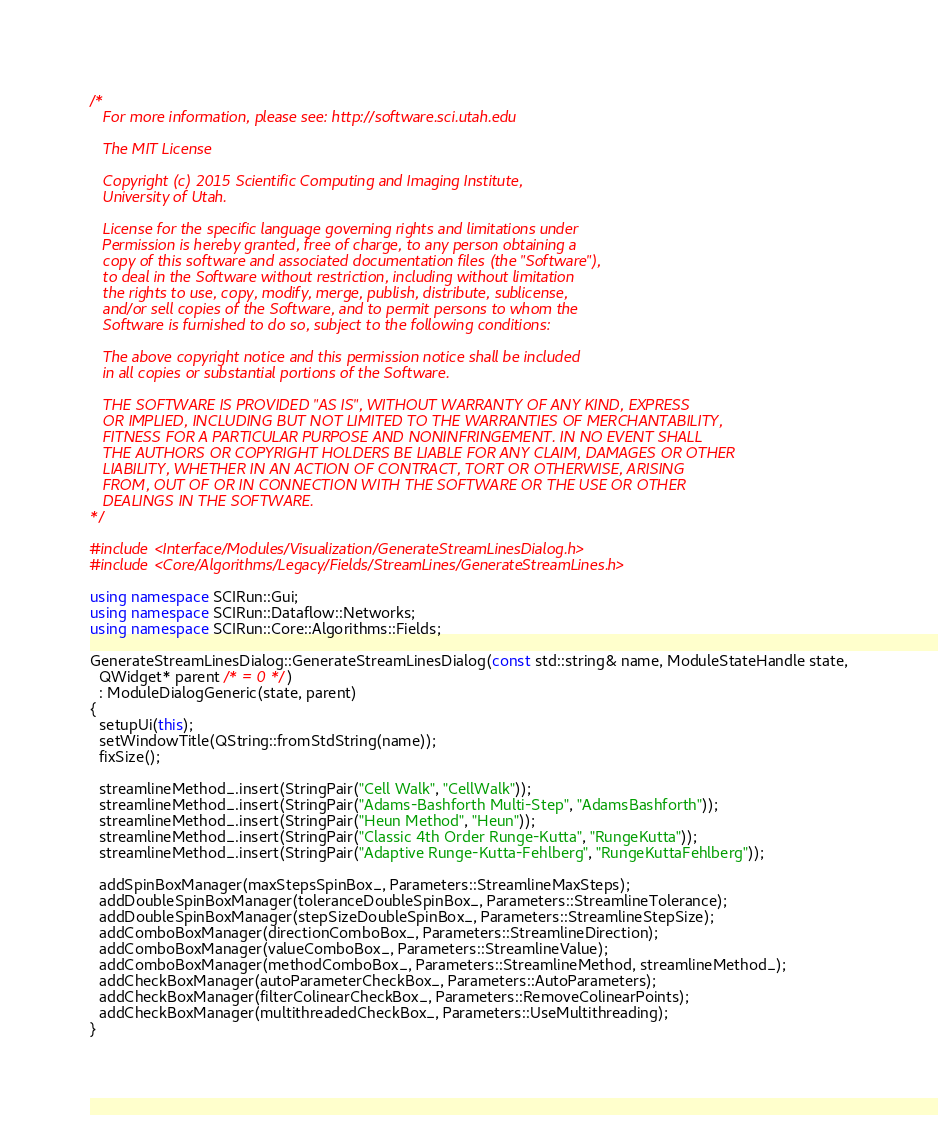Convert code to text. <code><loc_0><loc_0><loc_500><loc_500><_C++_>/*
   For more information, please see: http://software.sci.utah.edu

   The MIT License

   Copyright (c) 2015 Scientific Computing and Imaging Institute,
   University of Utah.

   License for the specific language governing rights and limitations under
   Permission is hereby granted, free of charge, to any person obtaining a
   copy of this software and associated documentation files (the "Software"),
   to deal in the Software without restriction, including without limitation
   the rights to use, copy, modify, merge, publish, distribute, sublicense,
   and/or sell copies of the Software, and to permit persons to whom the
   Software is furnished to do so, subject to the following conditions:

   The above copyright notice and this permission notice shall be included
   in all copies or substantial portions of the Software.

   THE SOFTWARE IS PROVIDED "AS IS", WITHOUT WARRANTY OF ANY KIND, EXPRESS
   OR IMPLIED, INCLUDING BUT NOT LIMITED TO THE WARRANTIES OF MERCHANTABILITY,
   FITNESS FOR A PARTICULAR PURPOSE AND NONINFRINGEMENT. IN NO EVENT SHALL
   THE AUTHORS OR COPYRIGHT HOLDERS BE LIABLE FOR ANY CLAIM, DAMAGES OR OTHER
   LIABILITY, WHETHER IN AN ACTION OF CONTRACT, TORT OR OTHERWISE, ARISING
   FROM, OUT OF OR IN CONNECTION WITH THE SOFTWARE OR THE USE OR OTHER
   DEALINGS IN THE SOFTWARE.
*/

#include <Interface/Modules/Visualization/GenerateStreamLinesDialog.h>
#include <Core/Algorithms/Legacy/Fields/StreamLines/GenerateStreamLines.h>

using namespace SCIRun::Gui;
using namespace SCIRun::Dataflow::Networks;
using namespace SCIRun::Core::Algorithms::Fields;

GenerateStreamLinesDialog::GenerateStreamLinesDialog(const std::string& name, ModuleStateHandle state,
  QWidget* parent /* = 0 */)
  : ModuleDialogGeneric(state, parent)
{
  setupUi(this);
  setWindowTitle(QString::fromStdString(name));
  fixSize();

  streamlineMethod_.insert(StringPair("Cell Walk", "CellWalk"));
  streamlineMethod_.insert(StringPair("Adams-Bashforth Multi-Step", "AdamsBashforth"));
  streamlineMethod_.insert(StringPair("Heun Method", "Heun"));
  streamlineMethod_.insert(StringPair("Classic 4th Order Runge-Kutta", "RungeKutta"));
  streamlineMethod_.insert(StringPair("Adaptive Runge-Kutta-Fehlberg", "RungeKuttaFehlberg"));

  addSpinBoxManager(maxStepsSpinBox_, Parameters::StreamlineMaxSteps);
  addDoubleSpinBoxManager(toleranceDoubleSpinBox_, Parameters::StreamlineTolerance);
  addDoubleSpinBoxManager(stepSizeDoubleSpinBox_, Parameters::StreamlineStepSize);
  addComboBoxManager(directionComboBox_, Parameters::StreamlineDirection);
  addComboBoxManager(valueComboBox_, Parameters::StreamlineValue);
  addComboBoxManager(methodComboBox_, Parameters::StreamlineMethod, streamlineMethod_);
  addCheckBoxManager(autoParameterCheckBox_, Parameters::AutoParameters);
  addCheckBoxManager(filterColinearCheckBox_, Parameters::RemoveColinearPoints);
  addCheckBoxManager(multithreadedCheckBox_, Parameters::UseMultithreading);
}
</code> 